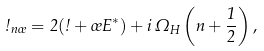<formula> <loc_0><loc_0><loc_500><loc_500>\omega _ { n \sigma } = 2 ( \omega + \sigma E ^ { * } ) + i \, \Omega _ { H } \left ( n + \frac { 1 } { 2 } \right ) ,</formula> 